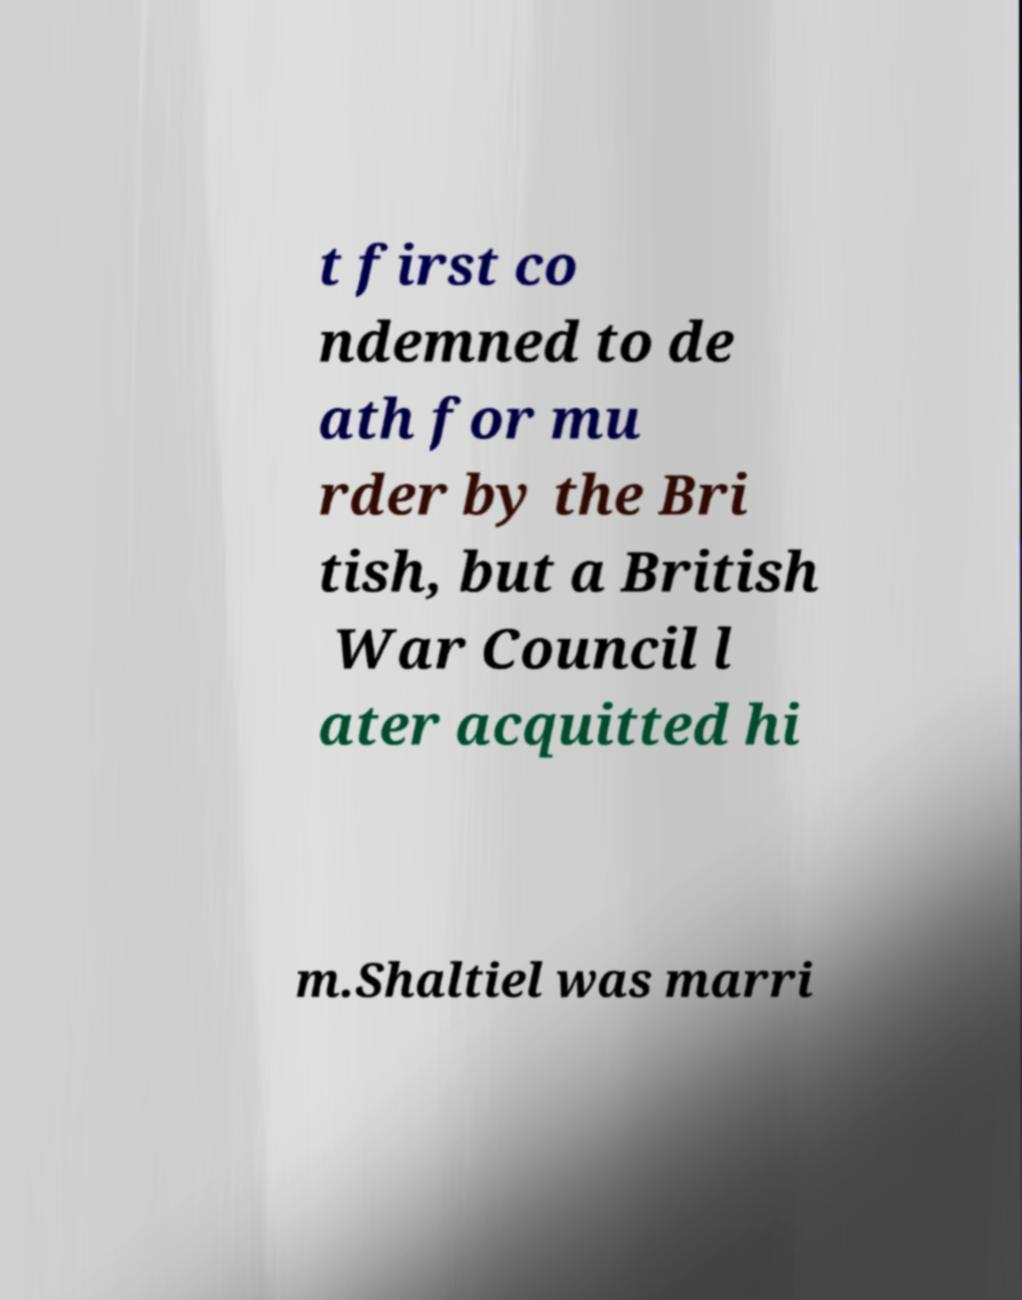Please read and relay the text visible in this image. What does it say? t first co ndemned to de ath for mu rder by the Bri tish, but a British War Council l ater acquitted hi m.Shaltiel was marri 